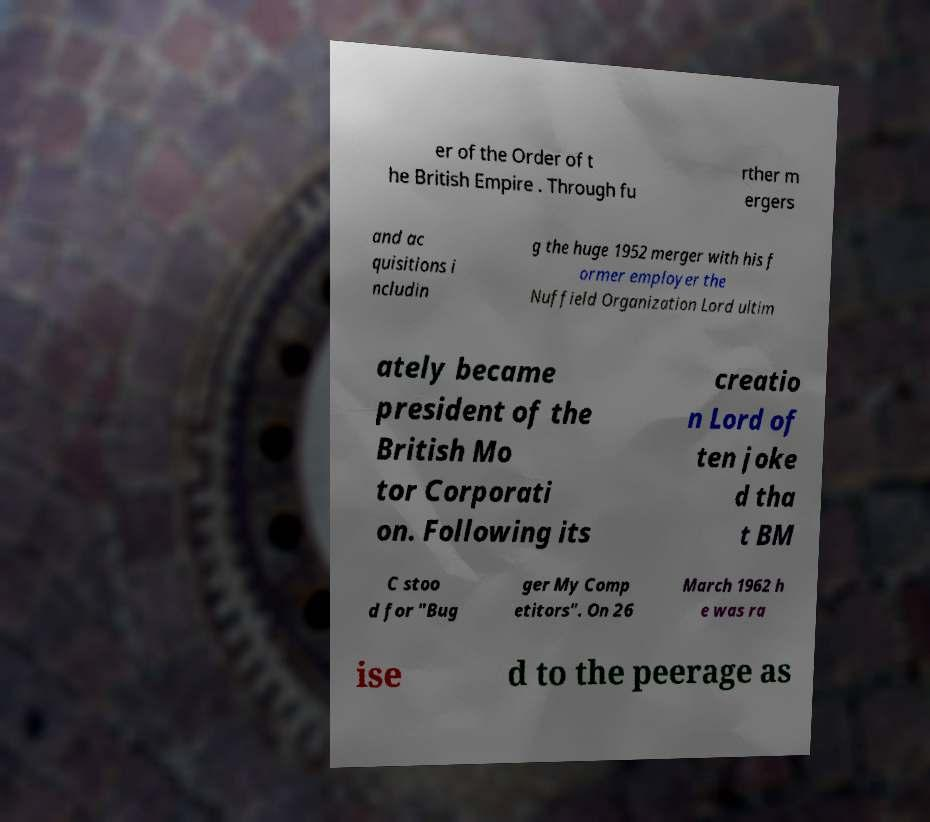Could you extract and type out the text from this image? er of the Order of t he British Empire . Through fu rther m ergers and ac quisitions i ncludin g the huge 1952 merger with his f ormer employer the Nuffield Organization Lord ultim ately became president of the British Mo tor Corporati on. Following its creatio n Lord of ten joke d tha t BM C stoo d for "Bug ger My Comp etitors". On 26 March 1962 h e was ra ise d to the peerage as 